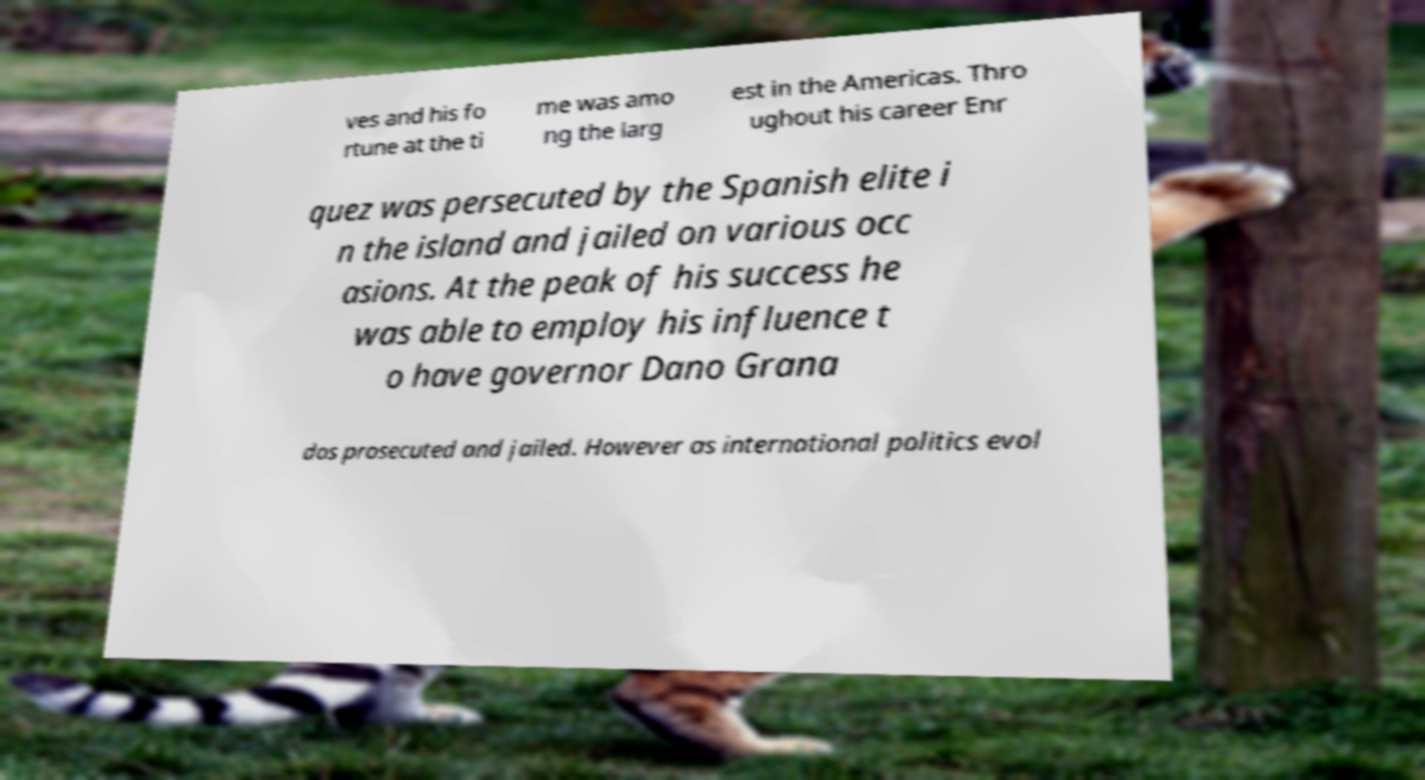I need the written content from this picture converted into text. Can you do that? ves and his fo rtune at the ti me was amo ng the larg est in the Americas. Thro ughout his career Enr quez was persecuted by the Spanish elite i n the island and jailed on various occ asions. At the peak of his success he was able to employ his influence t o have governor Dano Grana dos prosecuted and jailed. However as international politics evol 